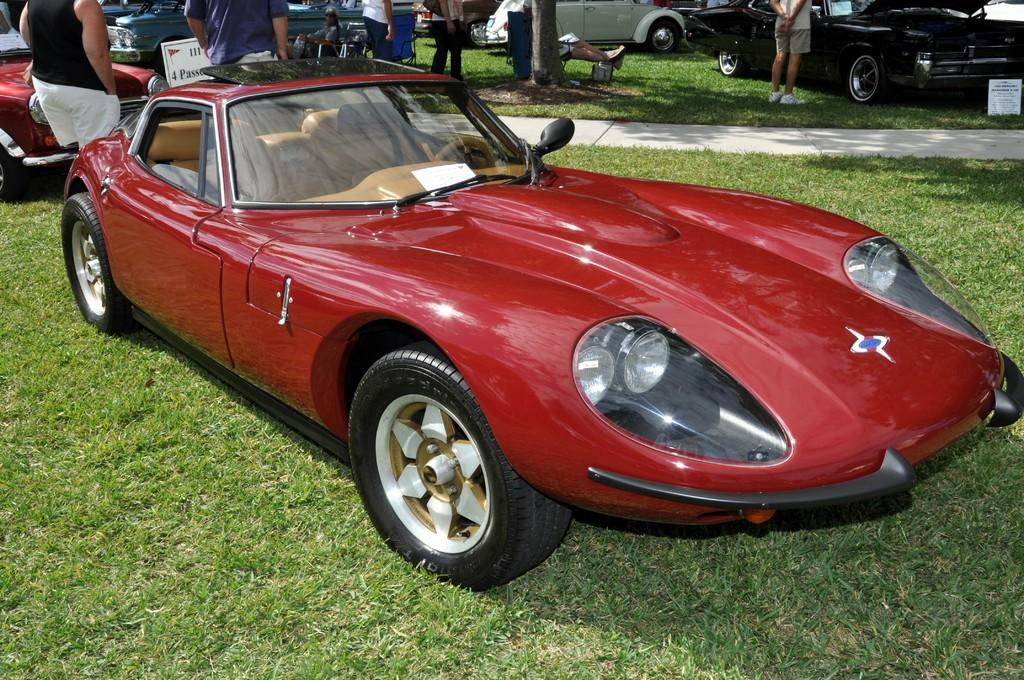What type of vehicle is in the image? There is a red car in the image. Where is the car located? The car is on the grass ground. What can be seen in the background of the image? There are many people and vehicles in the background of the image. What type of terrain is visible in the image? The grass is visible in the image. What type of jeans is the snake wearing in the image? There is no snake or jeans present in the image. 